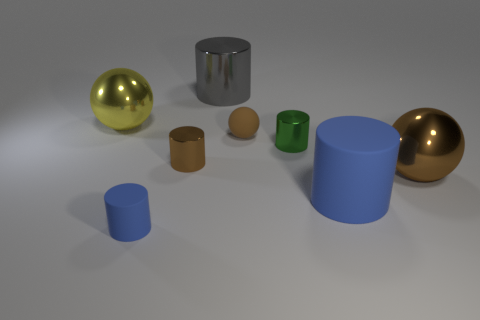There is a brown rubber object that is the same shape as the yellow object; what is its size?
Provide a short and direct response. Small. How many spheres are green metallic objects or red matte objects?
Offer a very short reply. 0. There is a cylinder that is the same color as the big matte thing; what is its material?
Your answer should be very brief. Rubber. Are there fewer small shiny cylinders in front of the big yellow sphere than large gray metallic objects that are right of the gray object?
Make the answer very short. No. What number of things are rubber cylinders on the right side of the tiny blue cylinder or small objects?
Give a very brief answer. 5. There is a metallic thing behind the sphere that is on the left side of the gray cylinder; what is its shape?
Provide a short and direct response. Cylinder. Is there a green rubber block of the same size as the green cylinder?
Provide a short and direct response. No. Is the number of big rubber spheres greater than the number of yellow things?
Provide a short and direct response. No. There is a rubber thing that is to the right of the small sphere; is its size the same as the blue matte thing on the left side of the rubber sphere?
Your response must be concise. No. How many balls are on the left side of the tiny brown metallic cylinder and in front of the matte ball?
Offer a terse response. 0. 